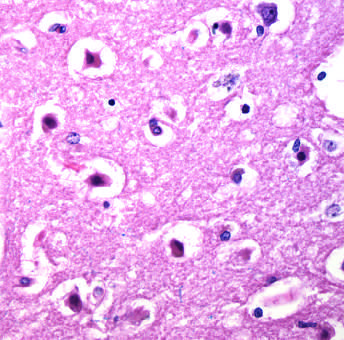what are pyknotic?
Answer the question using a single word or phrase. The nuclei 